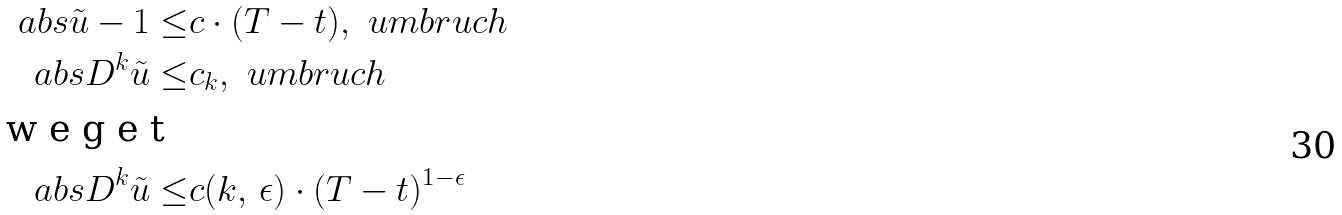Convert formula to latex. <formula><loc_0><loc_0><loc_500><loc_500>\ a b s { \tilde { u } - 1 } \leq & c \cdot ( T - t ) , \ u m b r u c h \\ \ a b s { D ^ { k } \tilde { u } } \leq & c _ { k } , \ u m b r u c h \intertext { w e g e t } \ a b s { D ^ { k } \tilde { u } } \leq & c ( k , \, \epsilon ) \cdot ( T - t ) ^ { 1 - \epsilon }</formula> 